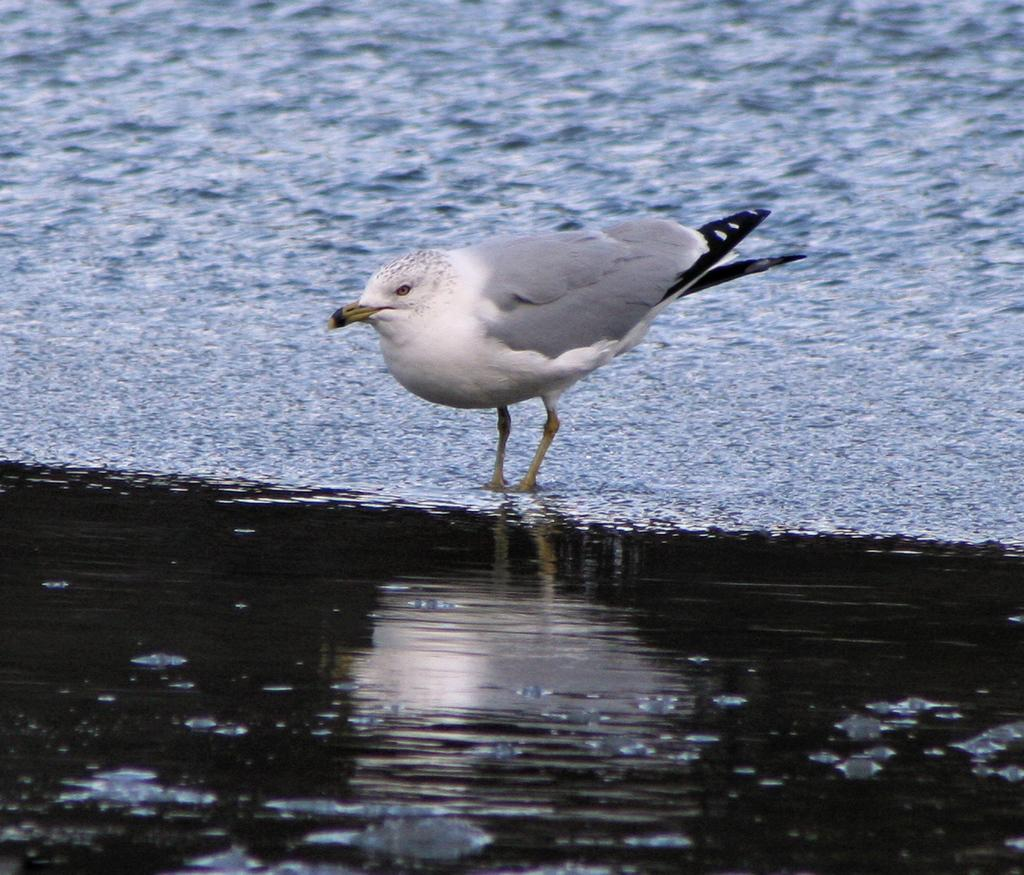What type of animal is present in the image? There is a bird in the image. Where is the bird located in the image? The bird is standing on the ground. How many ladybugs are flying over the bird in the image? There are no ladybugs present in the image. 